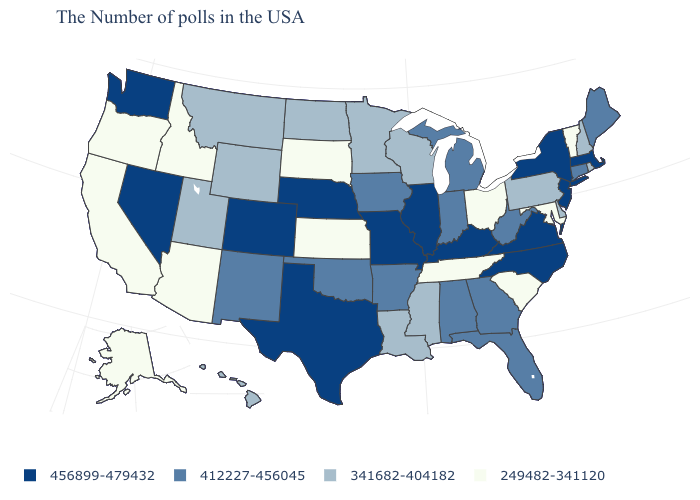What is the lowest value in the USA?
Write a very short answer. 249482-341120. Among the states that border Virginia , which have the lowest value?
Keep it brief. Maryland, Tennessee. Does Oklahoma have the same value as Vermont?
Answer briefly. No. What is the value of Florida?
Be succinct. 412227-456045. Does the map have missing data?
Keep it brief. No. Does Missouri have the same value as Rhode Island?
Short answer required. No. What is the value of Delaware?
Answer briefly. 341682-404182. Does the first symbol in the legend represent the smallest category?
Short answer required. No. Does Texas have a lower value than Virginia?
Answer briefly. No. What is the highest value in the USA?
Give a very brief answer. 456899-479432. Among the states that border Delaware , does New Jersey have the lowest value?
Concise answer only. No. What is the lowest value in states that border Illinois?
Short answer required. 341682-404182. Which states have the highest value in the USA?
Keep it brief. Massachusetts, New York, New Jersey, Virginia, North Carolina, Kentucky, Illinois, Missouri, Nebraska, Texas, Colorado, Nevada, Washington. Does Tennessee have the lowest value in the South?
Quick response, please. Yes. Does Wyoming have a higher value than Tennessee?
Answer briefly. Yes. 